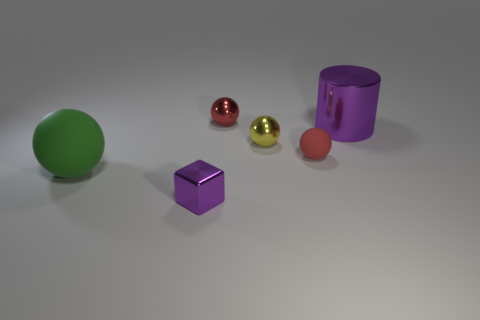Subtract all cyan cylinders. Subtract all red balls. How many cylinders are left? 1 Subtract all cyan spheres. How many red cylinders are left? 0 Add 4 purples. How many yellows exist? 0 Subtract all large metal objects. Subtract all tiny gray rubber spheres. How many objects are left? 5 Add 5 large purple shiny objects. How many large purple shiny objects are left? 6 Add 2 small matte balls. How many small matte balls exist? 3 Add 4 small yellow balls. How many objects exist? 10 Subtract all green balls. How many balls are left? 3 Subtract all large balls. How many balls are left? 3 Subtract 0 cyan cubes. How many objects are left? 6 